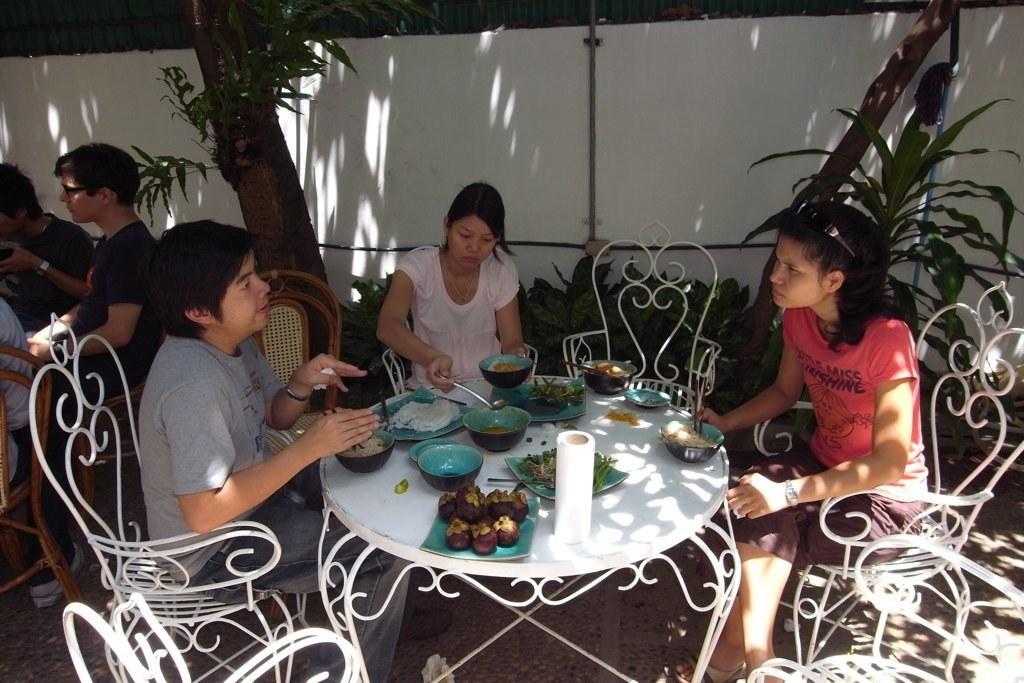How would you summarize this image in a sentence or two? This image is clicked outside. This is looking like a restaurant. There is a table in the middle and chairs around the table. People are sitting on the chairs. There are bowls, plates, eatables and tissues on the table. The table is and white colour. There is tree on the left side right side and left side too. There are people sitting on the left side. There are pipes in the middle to the wall. 